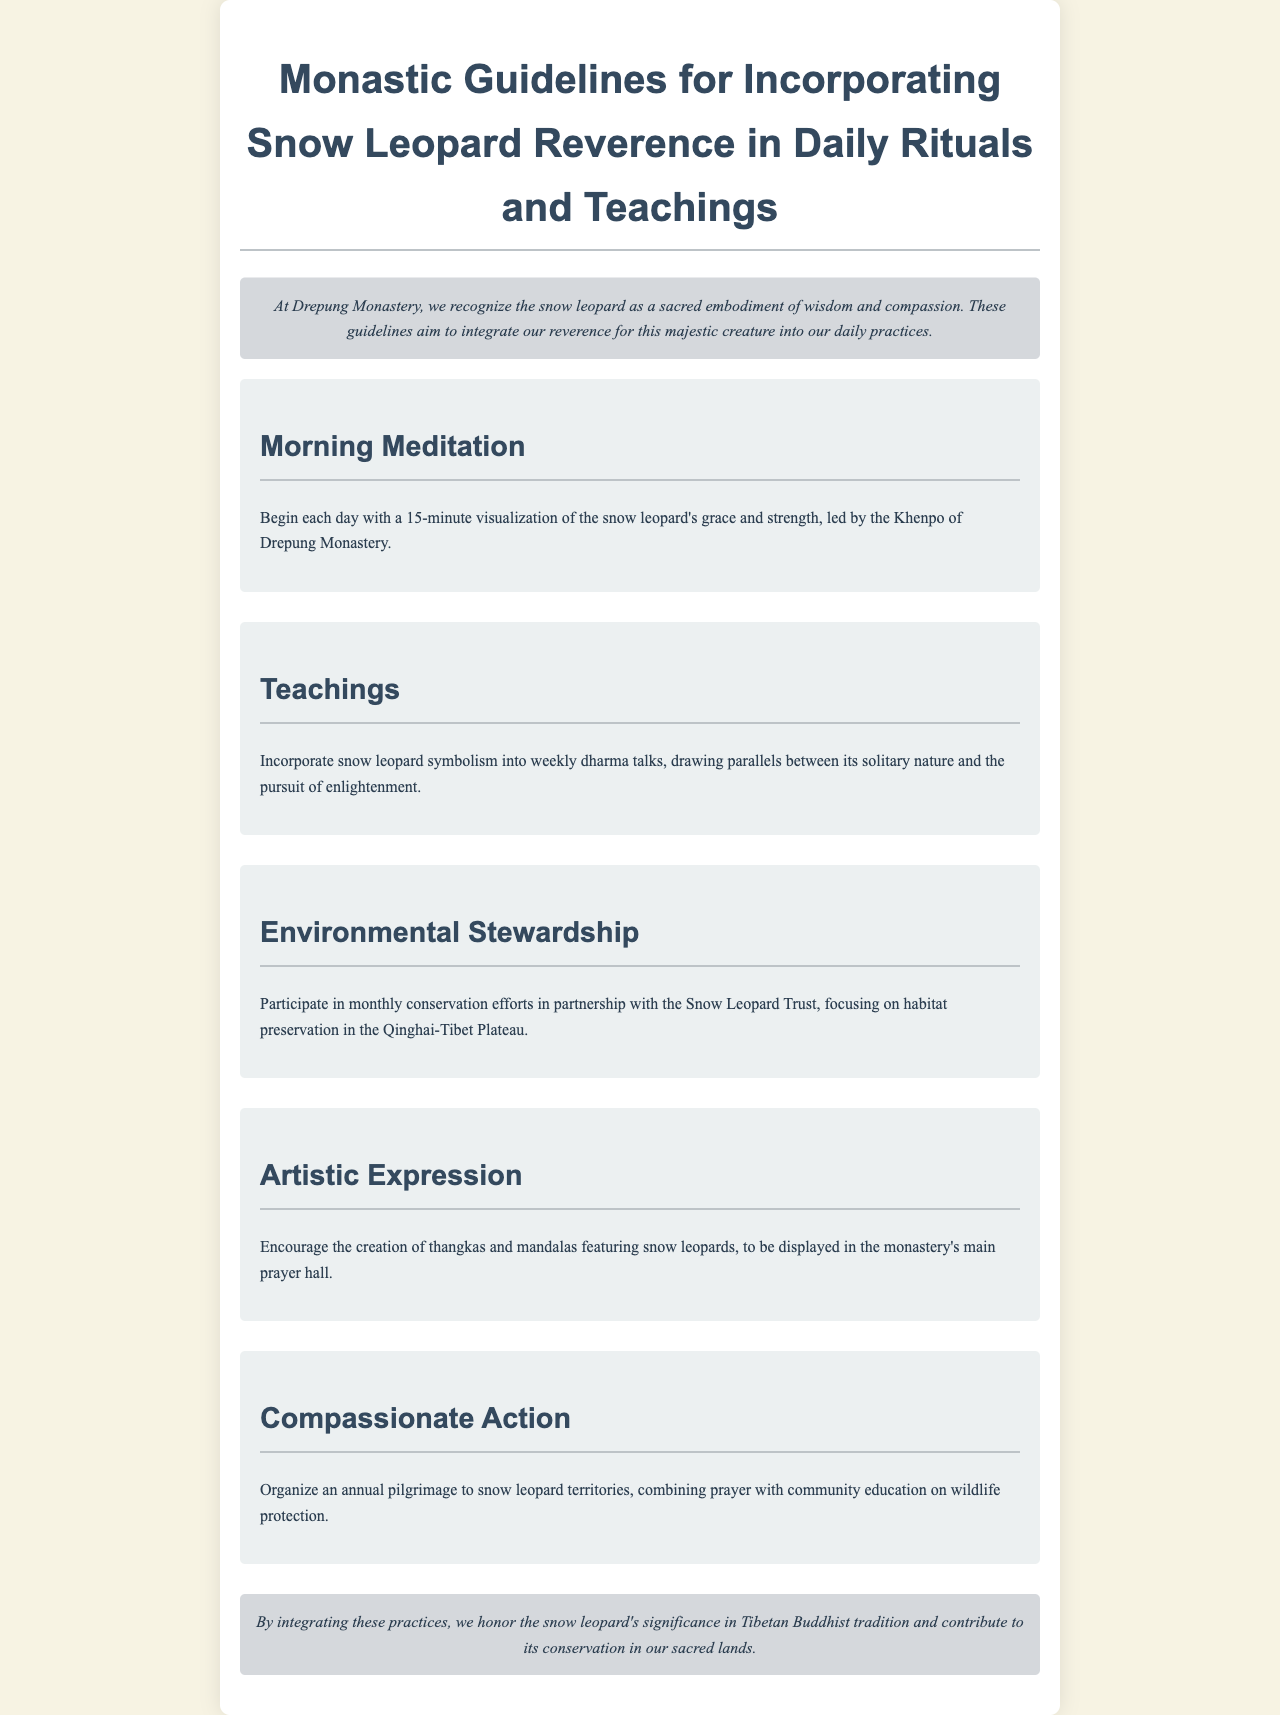What is the title of the document? The title is explicitly stated at the beginning of the document in the header section.
Answer: Monastic Guidelines for Incorporating Snow Leopard Reverence in Daily Rituals and Teachings Who leads the morning meditation? The document specifies the individual responsible for leading the morning meditation, which is a role within the monastery.
Answer: Khenpo of Drepung Monastery How long should the morning meditation last? The duration of the morning meditation is mentioned in the guidelines section regarding morning practices.
Answer: 15 minutes What kind of artistic expression is encouraged? The document includes a specific type of artistic expression related to snow leopards that is encouraged in the monastery.
Answer: Thangkas and mandalas What is the purpose of the annual pilgrimage? The document outlines the goal of the pilgrimage, combining spiritual and educational elements regarding wildlife.
Answer: Community education on wildlife protection How frequently are the conservation efforts conducted? The document articulates how often these efforts are to be executed and with which organization.
Answer: Monthly What is the sacred land referenced for conservation? The document refers to the location in question when discussing habitat preservation related to snow leopards.
Answer: Qinghai-Tibet Plateau What is the primary message of the conclusion? The conclusion encapsulates the document's intent of reverence and action regarding the snow leopard in monastic practice.
Answer: Honor the snow leopard's significance in Tibetan Buddhist tradition 